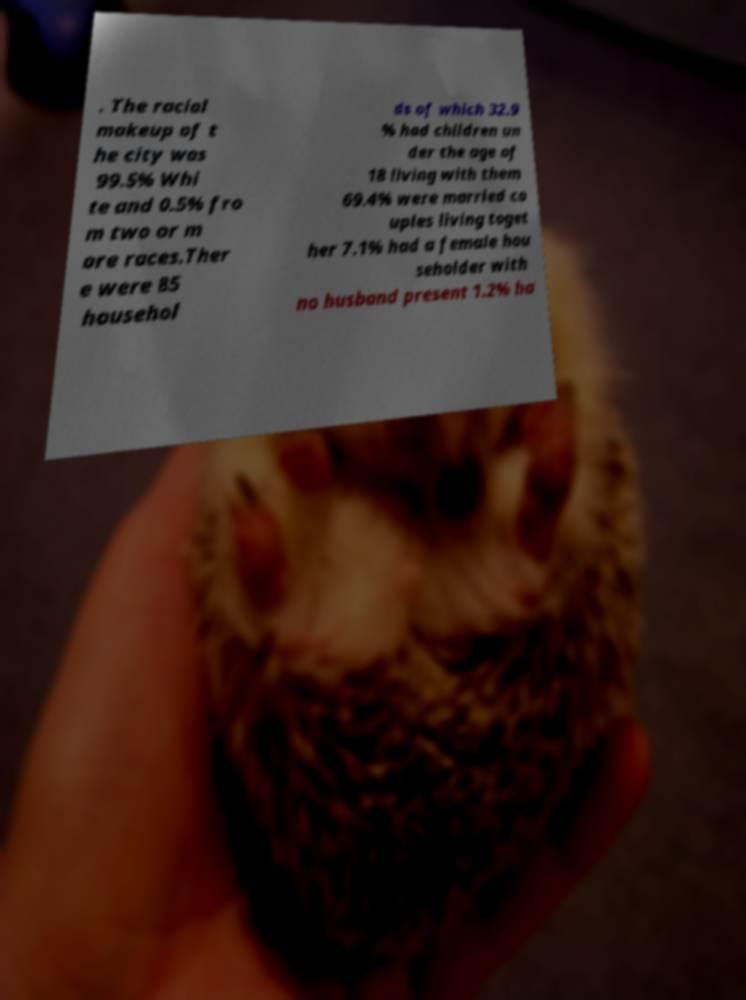Can you accurately transcribe the text from the provided image for me? . The racial makeup of t he city was 99.5% Whi te and 0.5% fro m two or m ore races.Ther e were 85 househol ds of which 32.9 % had children un der the age of 18 living with them 69.4% were married co uples living toget her 7.1% had a female hou seholder with no husband present 1.2% ha 